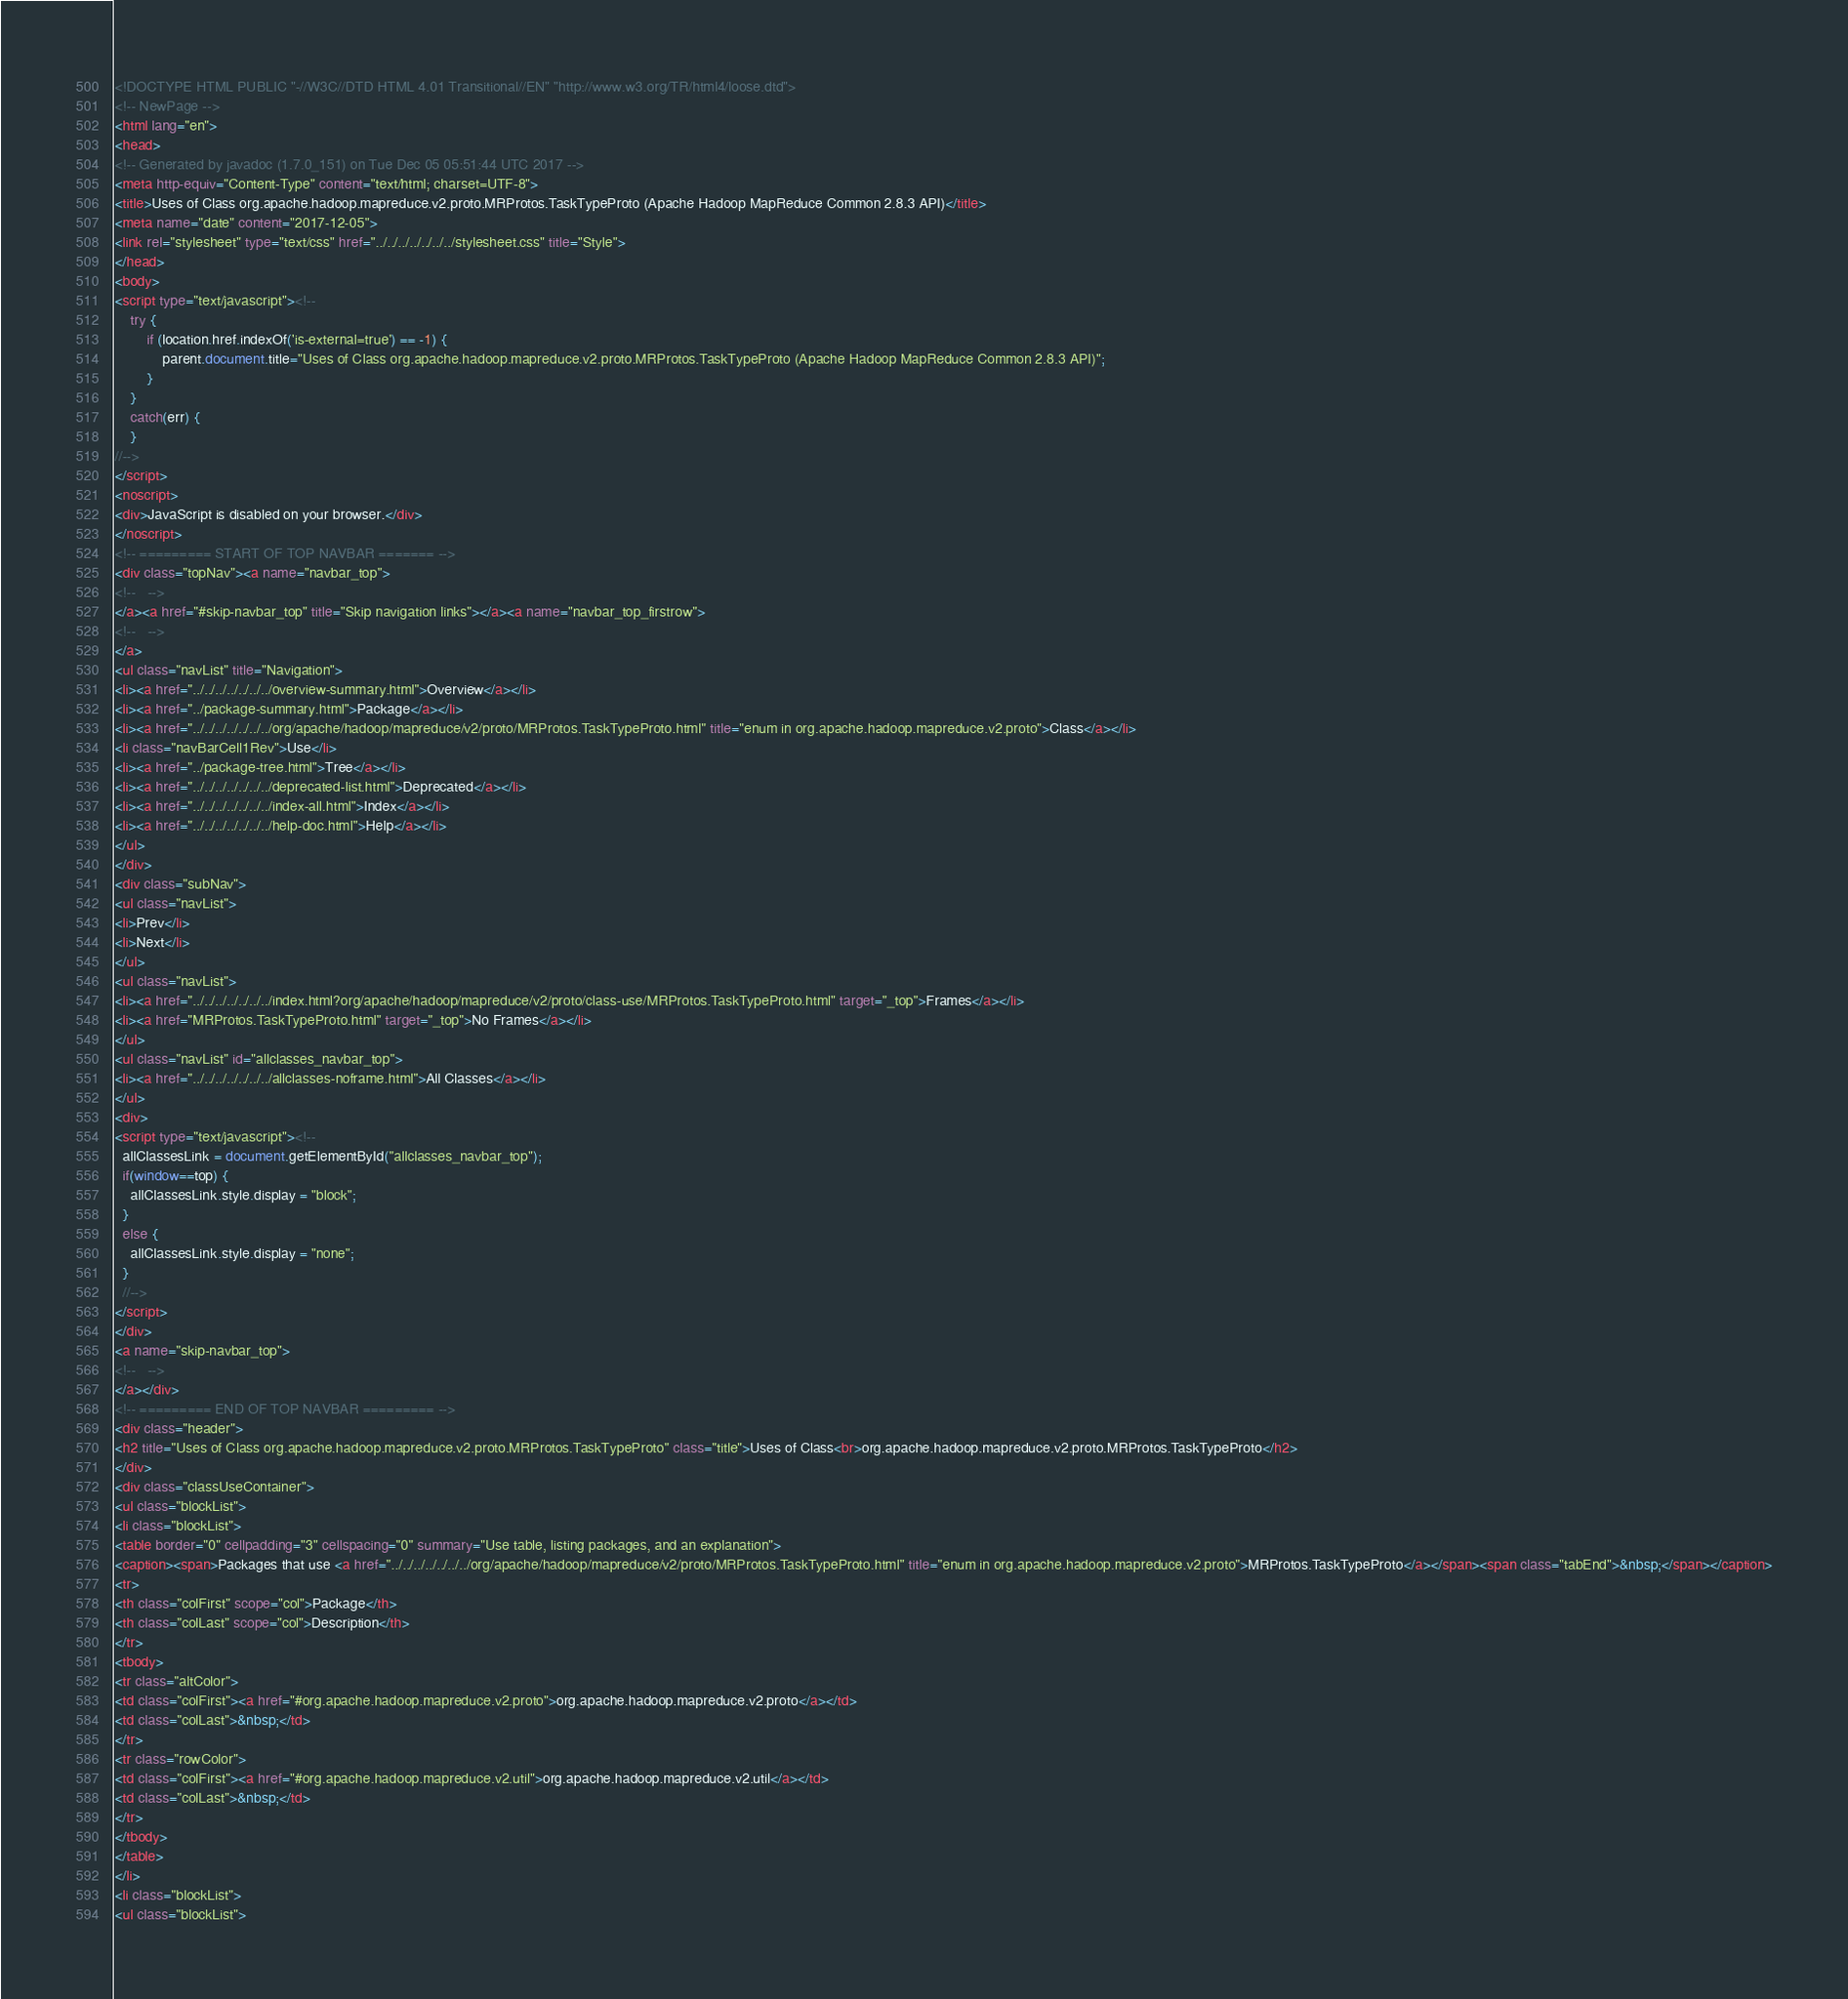<code> <loc_0><loc_0><loc_500><loc_500><_HTML_><!DOCTYPE HTML PUBLIC "-//W3C//DTD HTML 4.01 Transitional//EN" "http://www.w3.org/TR/html4/loose.dtd">
<!-- NewPage -->
<html lang="en">
<head>
<!-- Generated by javadoc (1.7.0_151) on Tue Dec 05 05:51:44 UTC 2017 -->
<meta http-equiv="Content-Type" content="text/html; charset=UTF-8">
<title>Uses of Class org.apache.hadoop.mapreduce.v2.proto.MRProtos.TaskTypeProto (Apache Hadoop MapReduce Common 2.8.3 API)</title>
<meta name="date" content="2017-12-05">
<link rel="stylesheet" type="text/css" href="../../../../../../../stylesheet.css" title="Style">
</head>
<body>
<script type="text/javascript"><!--
    try {
        if (location.href.indexOf('is-external=true') == -1) {
            parent.document.title="Uses of Class org.apache.hadoop.mapreduce.v2.proto.MRProtos.TaskTypeProto (Apache Hadoop MapReduce Common 2.8.3 API)";
        }
    }
    catch(err) {
    }
//-->
</script>
<noscript>
<div>JavaScript is disabled on your browser.</div>
</noscript>
<!-- ========= START OF TOP NAVBAR ======= -->
<div class="topNav"><a name="navbar_top">
<!--   -->
</a><a href="#skip-navbar_top" title="Skip navigation links"></a><a name="navbar_top_firstrow">
<!--   -->
</a>
<ul class="navList" title="Navigation">
<li><a href="../../../../../../../overview-summary.html">Overview</a></li>
<li><a href="../package-summary.html">Package</a></li>
<li><a href="../../../../../../../org/apache/hadoop/mapreduce/v2/proto/MRProtos.TaskTypeProto.html" title="enum in org.apache.hadoop.mapreduce.v2.proto">Class</a></li>
<li class="navBarCell1Rev">Use</li>
<li><a href="../package-tree.html">Tree</a></li>
<li><a href="../../../../../../../deprecated-list.html">Deprecated</a></li>
<li><a href="../../../../../../../index-all.html">Index</a></li>
<li><a href="../../../../../../../help-doc.html">Help</a></li>
</ul>
</div>
<div class="subNav">
<ul class="navList">
<li>Prev</li>
<li>Next</li>
</ul>
<ul class="navList">
<li><a href="../../../../../../../index.html?org/apache/hadoop/mapreduce/v2/proto/class-use/MRProtos.TaskTypeProto.html" target="_top">Frames</a></li>
<li><a href="MRProtos.TaskTypeProto.html" target="_top">No Frames</a></li>
</ul>
<ul class="navList" id="allclasses_navbar_top">
<li><a href="../../../../../../../allclasses-noframe.html">All Classes</a></li>
</ul>
<div>
<script type="text/javascript"><!--
  allClassesLink = document.getElementById("allclasses_navbar_top");
  if(window==top) {
    allClassesLink.style.display = "block";
  }
  else {
    allClassesLink.style.display = "none";
  }
  //-->
</script>
</div>
<a name="skip-navbar_top">
<!--   -->
</a></div>
<!-- ========= END OF TOP NAVBAR ========= -->
<div class="header">
<h2 title="Uses of Class org.apache.hadoop.mapreduce.v2.proto.MRProtos.TaskTypeProto" class="title">Uses of Class<br>org.apache.hadoop.mapreduce.v2.proto.MRProtos.TaskTypeProto</h2>
</div>
<div class="classUseContainer">
<ul class="blockList">
<li class="blockList">
<table border="0" cellpadding="3" cellspacing="0" summary="Use table, listing packages, and an explanation">
<caption><span>Packages that use <a href="../../../../../../../org/apache/hadoop/mapreduce/v2/proto/MRProtos.TaskTypeProto.html" title="enum in org.apache.hadoop.mapreduce.v2.proto">MRProtos.TaskTypeProto</a></span><span class="tabEnd">&nbsp;</span></caption>
<tr>
<th class="colFirst" scope="col">Package</th>
<th class="colLast" scope="col">Description</th>
</tr>
<tbody>
<tr class="altColor">
<td class="colFirst"><a href="#org.apache.hadoop.mapreduce.v2.proto">org.apache.hadoop.mapreduce.v2.proto</a></td>
<td class="colLast">&nbsp;</td>
</tr>
<tr class="rowColor">
<td class="colFirst"><a href="#org.apache.hadoop.mapreduce.v2.util">org.apache.hadoop.mapreduce.v2.util</a></td>
<td class="colLast">&nbsp;</td>
</tr>
</tbody>
</table>
</li>
<li class="blockList">
<ul class="blockList"></code> 